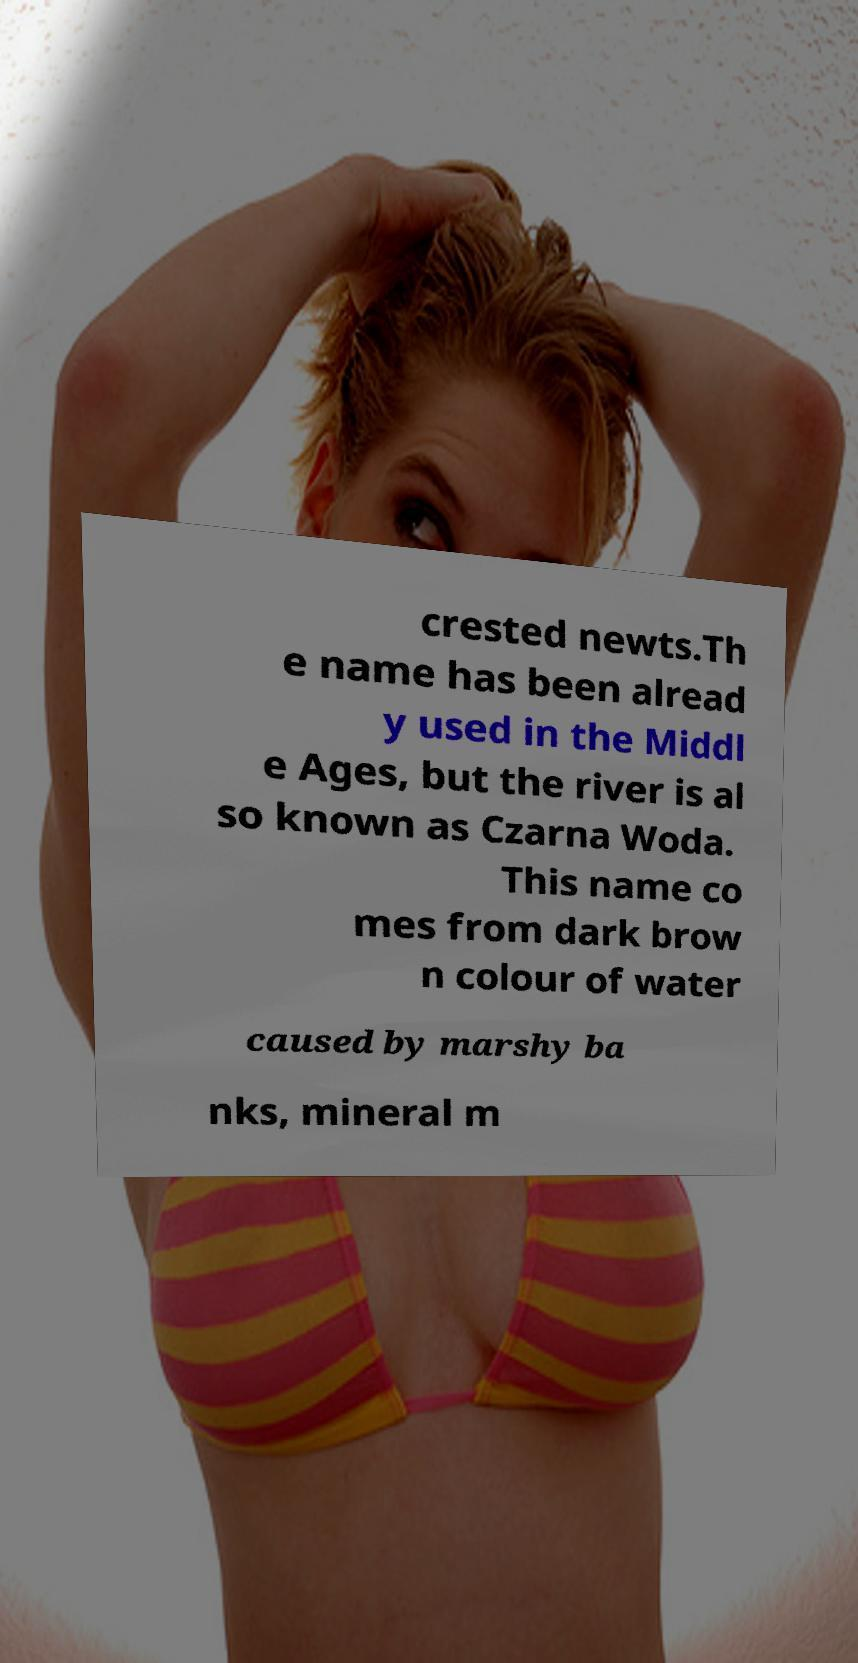Could you assist in decoding the text presented in this image and type it out clearly? crested newts.Th e name has been alread y used in the Middl e Ages, but the river is al so known as Czarna Woda. This name co mes from dark brow n colour of water caused by marshy ba nks, mineral m 